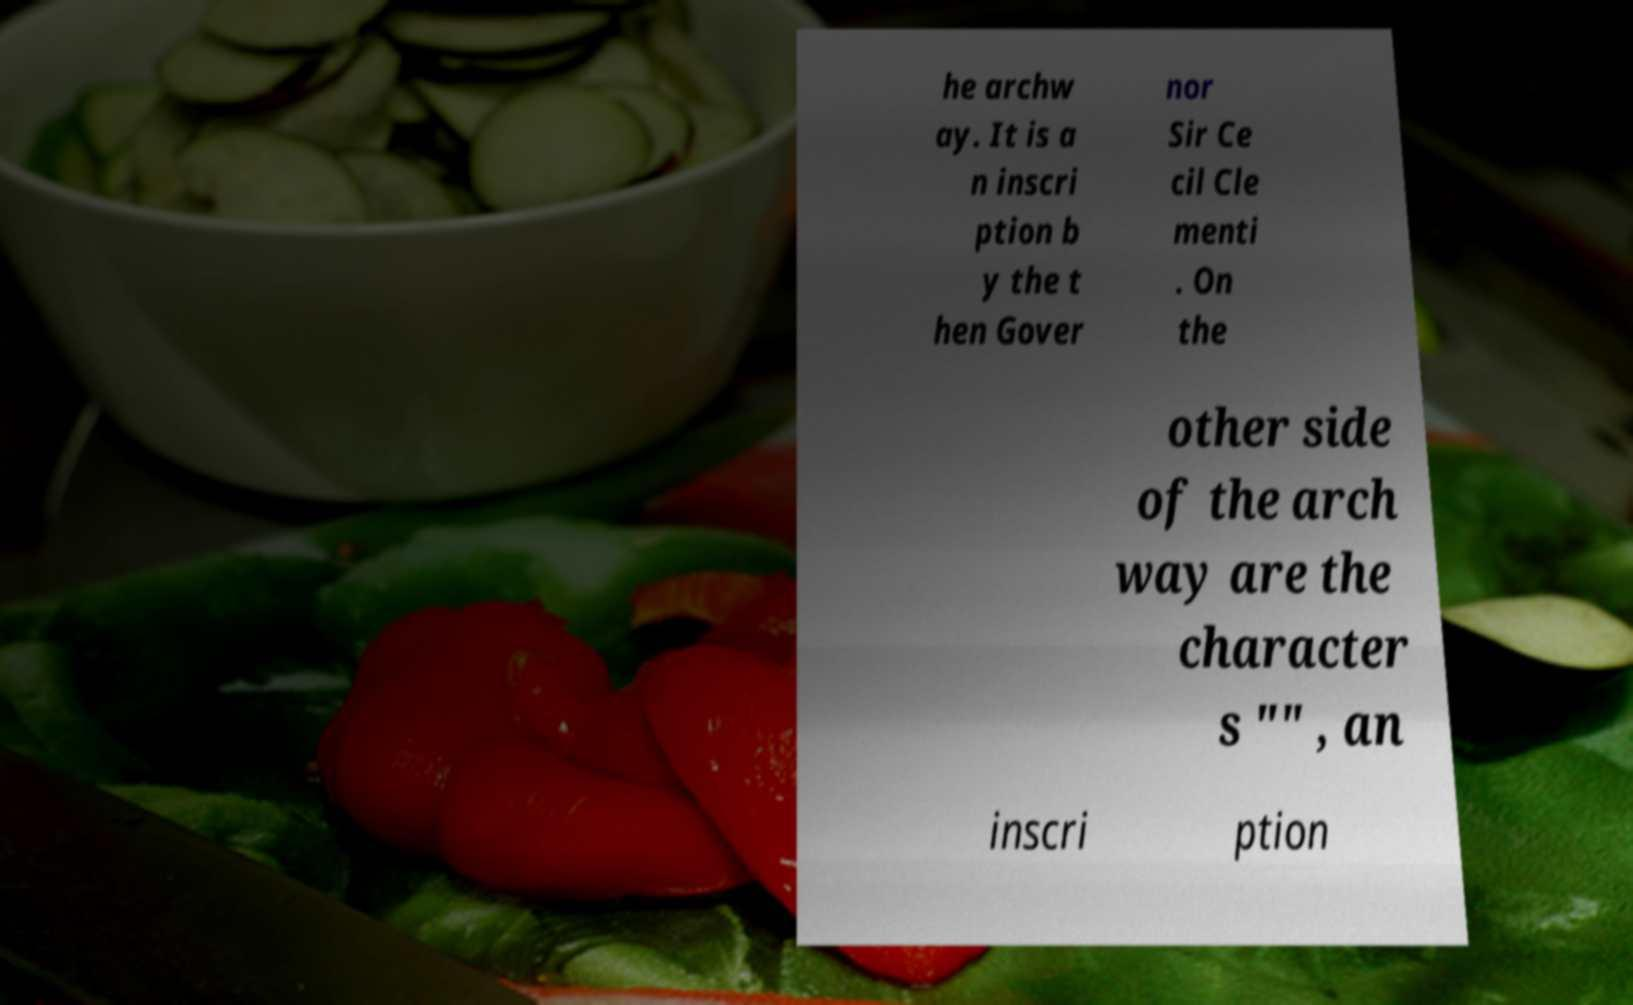Please read and relay the text visible in this image. What does it say? he archw ay. It is a n inscri ption b y the t hen Gover nor Sir Ce cil Cle menti . On the other side of the arch way are the character s "" , an inscri ption 